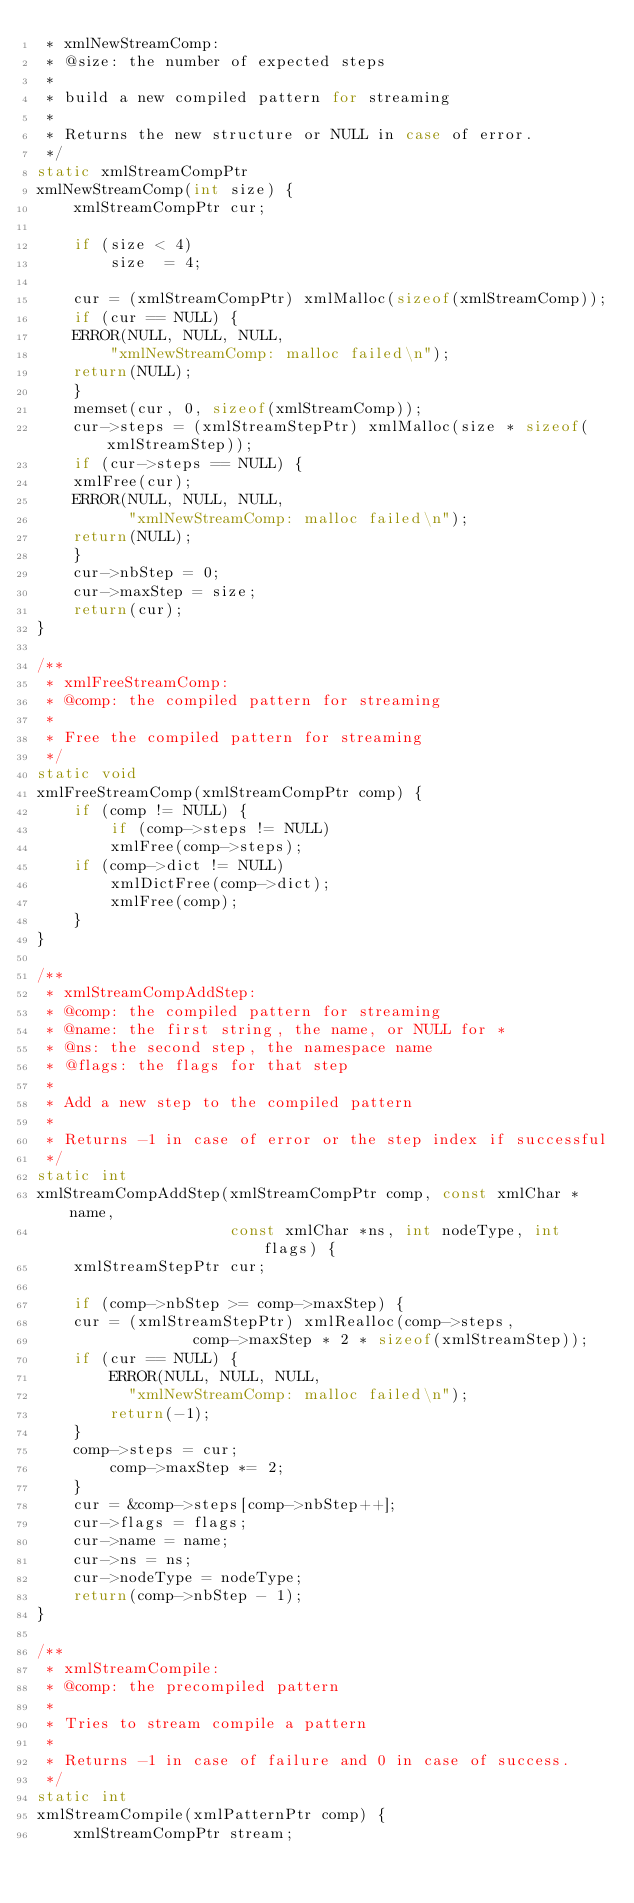<code> <loc_0><loc_0><loc_500><loc_500><_C_> * xmlNewStreamComp:
 * @size: the number of expected steps
 *
 * build a new compiled pattern for streaming
 *
 * Returns the new structure or NULL in case of error.
 */
static xmlStreamCompPtr
xmlNewStreamComp(int size) {
    xmlStreamCompPtr cur;

    if (size < 4)
        size  = 4;

    cur = (xmlStreamCompPtr) xmlMalloc(sizeof(xmlStreamComp));
    if (cur == NULL) {
	ERROR(NULL, NULL, NULL,
		"xmlNewStreamComp: malloc failed\n");
	return(NULL);
    }
    memset(cur, 0, sizeof(xmlStreamComp));
    cur->steps = (xmlStreamStepPtr) xmlMalloc(size * sizeof(xmlStreamStep));
    if (cur->steps == NULL) {
	xmlFree(cur);
	ERROR(NULL, NULL, NULL,
	      "xmlNewStreamComp: malloc failed\n");
	return(NULL);
    }
    cur->nbStep = 0;
    cur->maxStep = size;
    return(cur);
}

/**
 * xmlFreeStreamComp:
 * @comp: the compiled pattern for streaming
 *
 * Free the compiled pattern for streaming
 */
static void
xmlFreeStreamComp(xmlStreamCompPtr comp) {
    if (comp != NULL) {
        if (comp->steps != NULL)
	    xmlFree(comp->steps);
	if (comp->dict != NULL)
	    xmlDictFree(comp->dict);
        xmlFree(comp);
    }
}

/**
 * xmlStreamCompAddStep:
 * @comp: the compiled pattern for streaming
 * @name: the first string, the name, or NULL for *
 * @ns: the second step, the namespace name
 * @flags: the flags for that step
 *
 * Add a new step to the compiled pattern
 *
 * Returns -1 in case of error or the step index if successful
 */
static int
xmlStreamCompAddStep(xmlStreamCompPtr comp, const xmlChar *name,
                     const xmlChar *ns, int nodeType, int flags) {
    xmlStreamStepPtr cur;

    if (comp->nbStep >= comp->maxStep) {
	cur = (xmlStreamStepPtr) xmlRealloc(comp->steps,
				 comp->maxStep * 2 * sizeof(xmlStreamStep));
	if (cur == NULL) {
	    ERROR(NULL, NULL, NULL,
		  "xmlNewStreamComp: malloc failed\n");
	    return(-1);
	}
	comp->steps = cur;
        comp->maxStep *= 2;
    }
    cur = &comp->steps[comp->nbStep++];
    cur->flags = flags;
    cur->name = name;
    cur->ns = ns;
    cur->nodeType = nodeType;
    return(comp->nbStep - 1);
}

/**
 * xmlStreamCompile:
 * @comp: the precompiled pattern
 *
 * Tries to stream compile a pattern
 *
 * Returns -1 in case of failure and 0 in case of success.
 */
static int
xmlStreamCompile(xmlPatternPtr comp) {
    xmlStreamCompPtr stream;</code> 